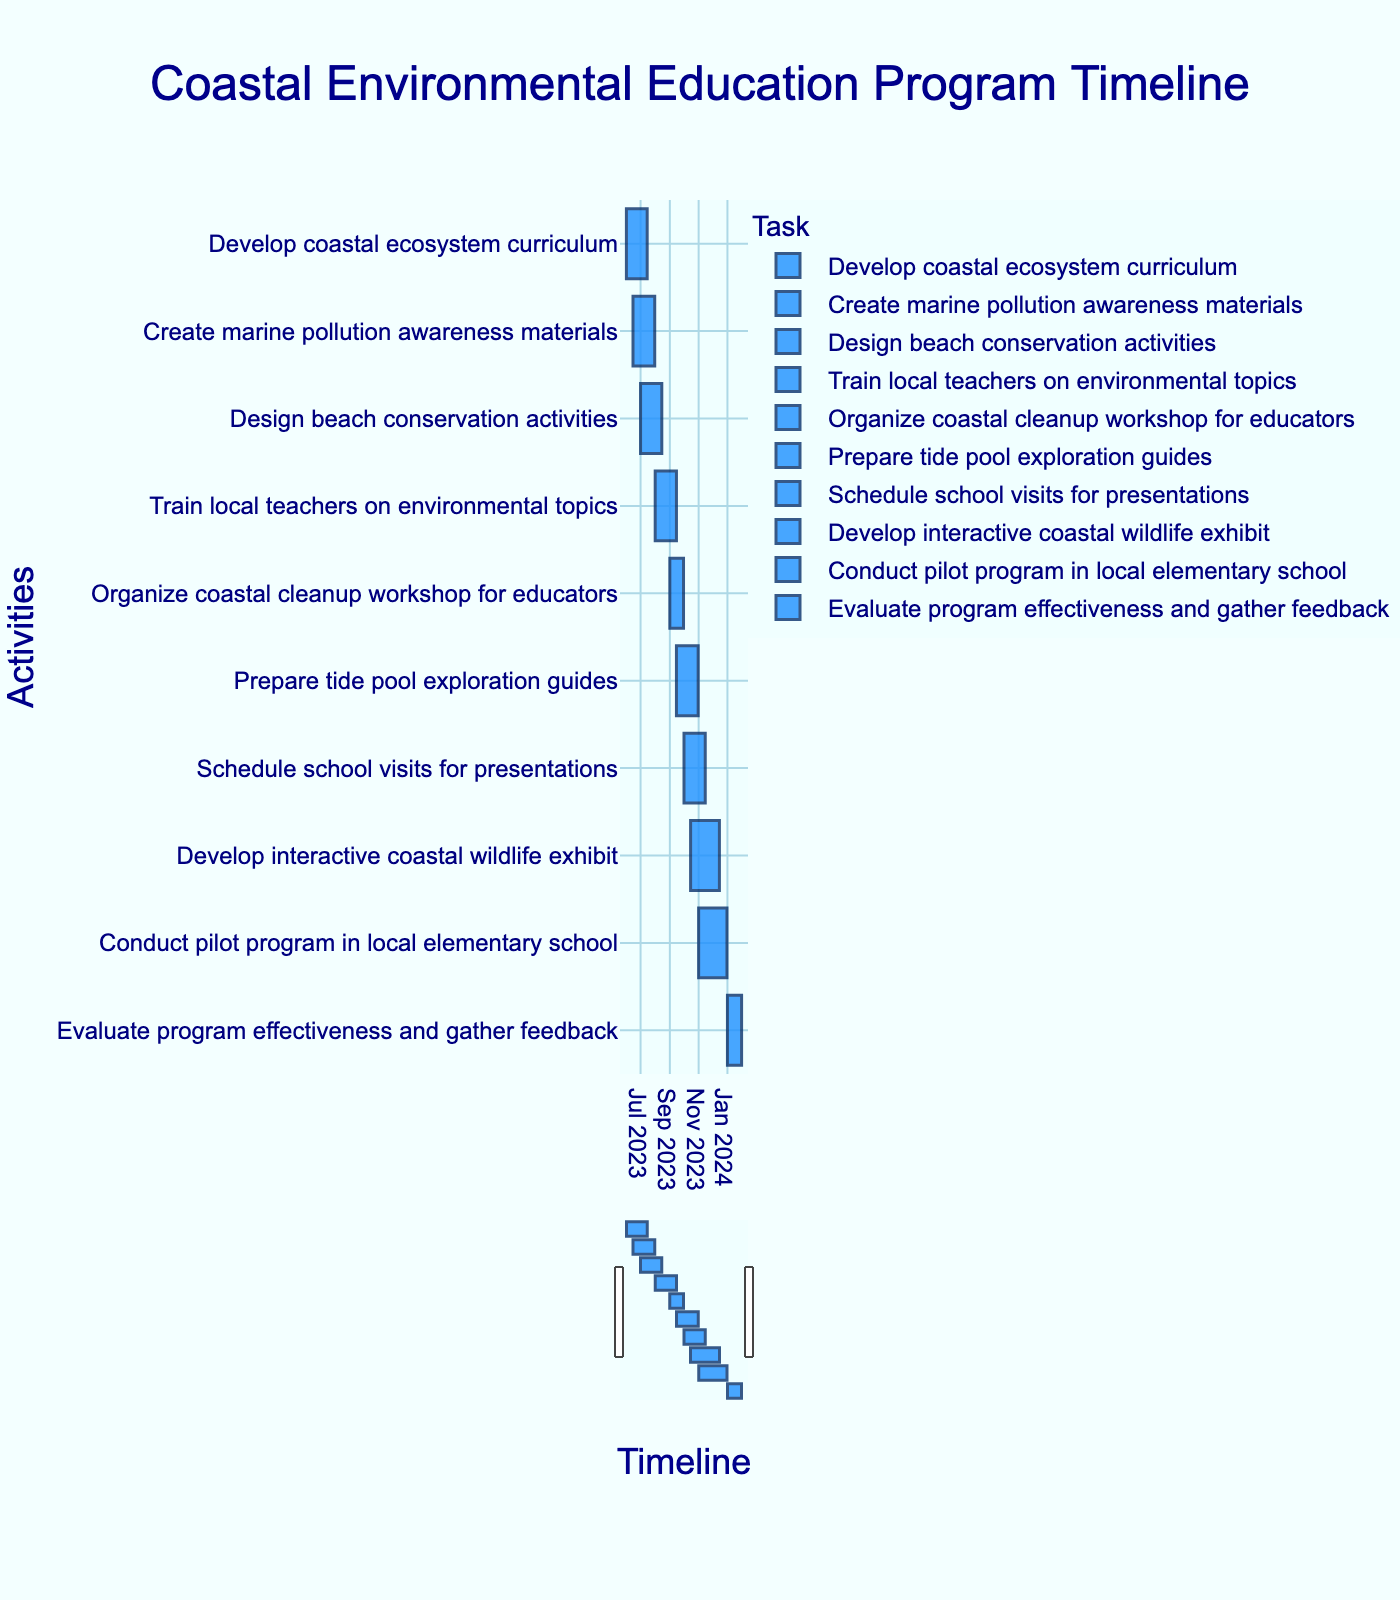What activity begins immediately after the "Develop coastal ecosystem curriculum" ends? The "Develop coastal ecosystem curriculum" task ends on July 15, 2023. By looking at the next starting date in the Gantt chart, the "Design beach conservation activities" task starts on July 1, 2023, overlapping partially. However, the nearest subsequent task without overlap is "Create marine pollution awareness materials".
Answer: Create marine pollution awareness materials Which two tasks overlap in September 2023? In the Gantt chart, "Train local teachers on environmental topics" and "Organize coastal cleanup workshop for educators" overlap in September 2023. This can be seen because both tasks have portions extending into September.
Answer: Train local teachers on environmental topics and Organize coastal cleanup workshop for educators When does the "Prepare tide pool exploration guides" activity begin and end? Refer to the Gantt chart's timeline for the "Prepare tide pool exploration guides" task. It shows a start date of September 15, 2023, and an end date of October 31, 2023.
Answer: September 15, 2023 - October 31, 2023 What is the total duration of the "Conduct pilot program in local elementary school"? The "Conduct pilot program in local elementary school" starts on November 1, 2023, and ends on December 31, 2023. By calculating the days between these dates: 31 (Dec) - 1 (Nov) + 1 = 61 days.
Answer: 61 days What is the last scheduled activity in the timeline? In the Gantt chart, the last task listed with the furthest end date is "Evaluate program effectiveness and gather feedback," which ends on January 31, 2024.
Answer: Evaluate program effectiveness and gather feedback Which task starts closest to the mid-year point (June 30)? Looking at the timeline around June 30, two tasks are near this date. "Develop coastal ecosystem curriculum" starts on June 1, 2023, but "Create marine pollution awareness materials" starts closely on June 15, 2023. Between the two, "Create marine pollution awareness materials" is closest to June 30.
Answer: Create marine pollution awareness materials How many activities are scheduled to continue into October 2023? Within the Gantt chart, the activities that extend into October 2023 are "Prepare tide pool exploration guides" and "Schedule school visits for presentations" and "Develop interactive coastal wildlife exhibit". Counting these overlaps, there are three tasks.
Answer: 3 activities Which task has the longest duration, and what is its length? To find the task with the longest duration, compare the start and end dates of each task. Observing the Gantt chart, "Develop interactive coastal wildlife exhibit" spans from October 15, 2023, to December 15, 2023, totaling 61 days. This is the longest duration among all tasks.
Answer: Develop interactive coastal wildlife exhibit, 61 days 